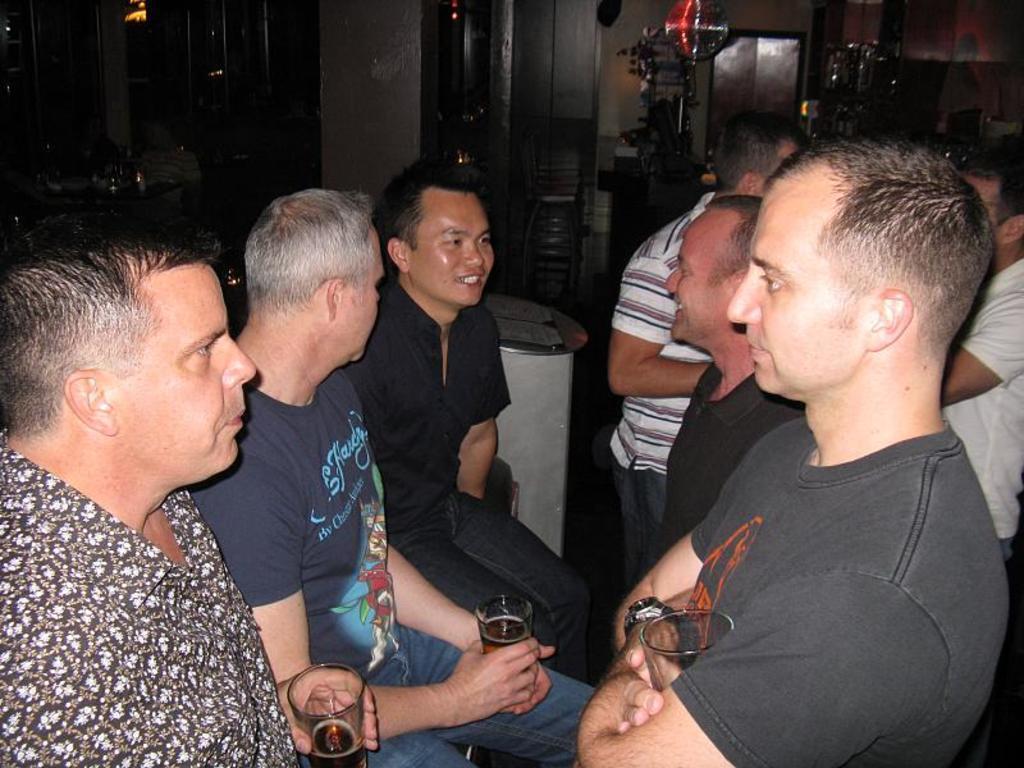Can you describe this image briefly? In this image there are three persons sitting and holding glasses, two persons standing, and in the background there are group of people standing, cupboards. 